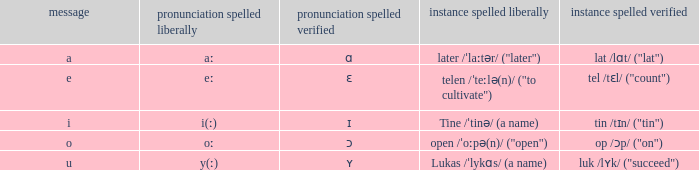What is letter, when illustration spelled verified is "tin /tɪn/ ("tin")"? I. 